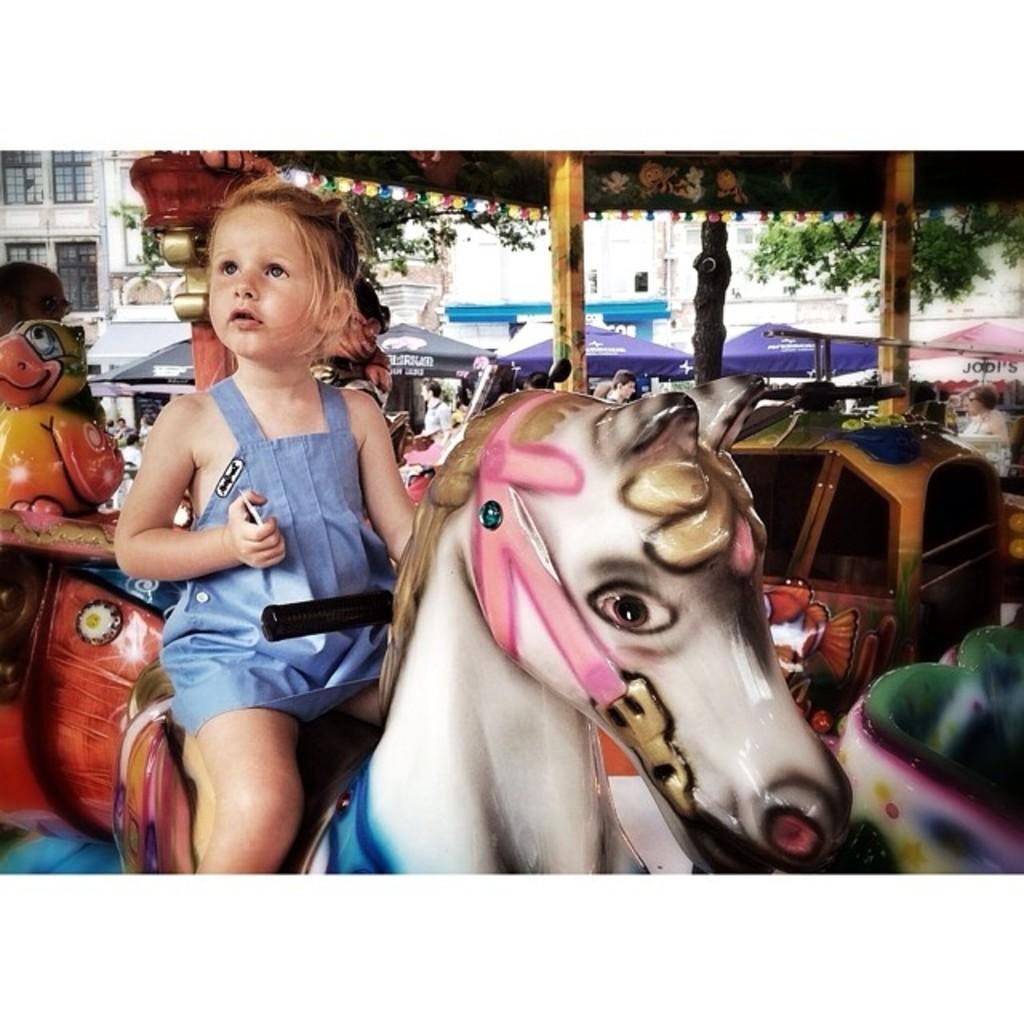Describe this image in one or two sentences. In this image there is a baby girl sitting in a toy horse , and the back ground there is tree, building , tent. 